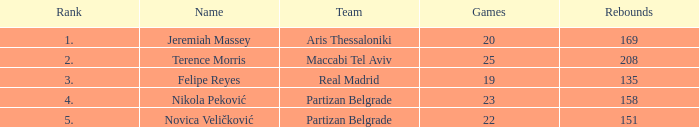How many Rebounds did Novica Veličković get in less than 22 Games? None. 